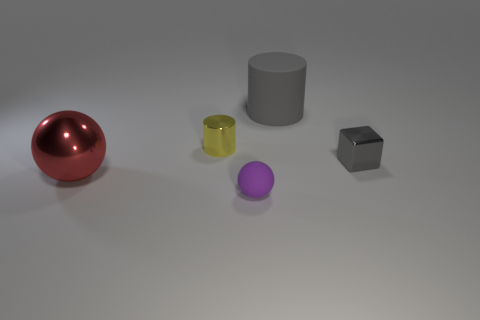Are any big purple objects visible?
Make the answer very short. No. What is the object that is on the left side of the small purple rubber sphere and to the right of the big sphere made of?
Give a very brief answer. Metal. Are there more shiny objects that are on the left side of the small sphere than balls that are in front of the large gray cylinder?
Offer a terse response. No. Is there a yellow shiny thing of the same size as the metallic cylinder?
Provide a short and direct response. No. What size is the metallic object on the left side of the cylinder that is left of the matte thing to the right of the small matte ball?
Your answer should be compact. Large. The large sphere has what color?
Make the answer very short. Red. Is the number of spheres behind the small purple matte thing greater than the number of green matte blocks?
Provide a succinct answer. Yes. There is a gray shiny object; what number of metallic cylinders are in front of it?
Offer a very short reply. 0. There is a big thing that is the same color as the small metallic block; what shape is it?
Provide a succinct answer. Cylinder. There is a matte object behind the object that is to the left of the yellow shiny thing; is there a purple rubber object on the left side of it?
Offer a very short reply. Yes. 